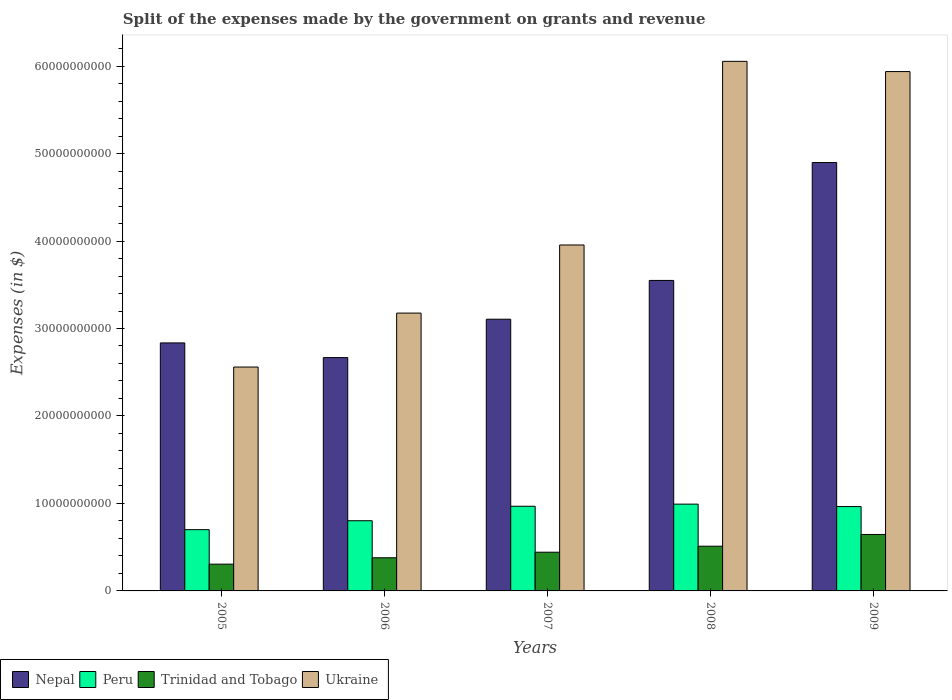How many different coloured bars are there?
Your answer should be very brief. 4. Are the number of bars per tick equal to the number of legend labels?
Give a very brief answer. Yes. How many bars are there on the 5th tick from the right?
Provide a succinct answer. 4. What is the label of the 2nd group of bars from the left?
Provide a short and direct response. 2006. In how many cases, is the number of bars for a given year not equal to the number of legend labels?
Keep it short and to the point. 0. What is the expenses made by the government on grants and revenue in Ukraine in 2005?
Keep it short and to the point. 2.56e+1. Across all years, what is the maximum expenses made by the government on grants and revenue in Nepal?
Provide a succinct answer. 4.90e+1. Across all years, what is the minimum expenses made by the government on grants and revenue in Ukraine?
Ensure brevity in your answer.  2.56e+1. In which year was the expenses made by the government on grants and revenue in Ukraine maximum?
Make the answer very short. 2008. What is the total expenses made by the government on grants and revenue in Trinidad and Tobago in the graph?
Your answer should be compact. 2.28e+1. What is the difference between the expenses made by the government on grants and revenue in Ukraine in 2006 and that in 2007?
Offer a very short reply. -7.79e+09. What is the difference between the expenses made by the government on grants and revenue in Ukraine in 2007 and the expenses made by the government on grants and revenue in Trinidad and Tobago in 2005?
Keep it short and to the point. 3.65e+1. What is the average expenses made by the government on grants and revenue in Peru per year?
Provide a succinct answer. 8.85e+09. In the year 2007, what is the difference between the expenses made by the government on grants and revenue in Nepal and expenses made by the government on grants and revenue in Trinidad and Tobago?
Provide a short and direct response. 2.66e+1. What is the ratio of the expenses made by the government on grants and revenue in Trinidad and Tobago in 2005 to that in 2007?
Your answer should be very brief. 0.69. Is the expenses made by the government on grants and revenue in Trinidad and Tobago in 2006 less than that in 2007?
Your answer should be compact. Yes. Is the difference between the expenses made by the government on grants and revenue in Nepal in 2007 and 2008 greater than the difference between the expenses made by the government on grants and revenue in Trinidad and Tobago in 2007 and 2008?
Offer a terse response. No. What is the difference between the highest and the second highest expenses made by the government on grants and revenue in Trinidad and Tobago?
Give a very brief answer. 1.34e+09. What is the difference between the highest and the lowest expenses made by the government on grants and revenue in Ukraine?
Ensure brevity in your answer.  3.49e+1. Is the sum of the expenses made by the government on grants and revenue in Peru in 2008 and 2009 greater than the maximum expenses made by the government on grants and revenue in Nepal across all years?
Your response must be concise. No. Is it the case that in every year, the sum of the expenses made by the government on grants and revenue in Ukraine and expenses made by the government on grants and revenue in Trinidad and Tobago is greater than the sum of expenses made by the government on grants and revenue in Peru and expenses made by the government on grants and revenue in Nepal?
Give a very brief answer. Yes. What does the 2nd bar from the right in 2007 represents?
Provide a succinct answer. Trinidad and Tobago. Is it the case that in every year, the sum of the expenses made by the government on grants and revenue in Trinidad and Tobago and expenses made by the government on grants and revenue in Peru is greater than the expenses made by the government on grants and revenue in Nepal?
Give a very brief answer. No. Are all the bars in the graph horizontal?
Offer a terse response. No. How many years are there in the graph?
Your answer should be compact. 5. What is the difference between two consecutive major ticks on the Y-axis?
Provide a succinct answer. 1.00e+1. Does the graph contain any zero values?
Provide a short and direct response. No. What is the title of the graph?
Your answer should be very brief. Split of the expenses made by the government on grants and revenue. What is the label or title of the Y-axis?
Offer a terse response. Expenses (in $). What is the Expenses (in $) in Nepal in 2005?
Provide a succinct answer. 2.84e+1. What is the Expenses (in $) of Peru in 2005?
Give a very brief answer. 7.00e+09. What is the Expenses (in $) in Trinidad and Tobago in 2005?
Provide a short and direct response. 3.06e+09. What is the Expenses (in $) of Ukraine in 2005?
Offer a terse response. 2.56e+1. What is the Expenses (in $) in Nepal in 2006?
Provide a succinct answer. 2.67e+1. What is the Expenses (in $) of Peru in 2006?
Provide a succinct answer. 8.02e+09. What is the Expenses (in $) of Trinidad and Tobago in 2006?
Your answer should be very brief. 3.79e+09. What is the Expenses (in $) of Ukraine in 2006?
Your answer should be very brief. 3.18e+1. What is the Expenses (in $) in Nepal in 2007?
Keep it short and to the point. 3.11e+1. What is the Expenses (in $) of Peru in 2007?
Keep it short and to the point. 9.68e+09. What is the Expenses (in $) in Trinidad and Tobago in 2007?
Provide a short and direct response. 4.42e+09. What is the Expenses (in $) in Ukraine in 2007?
Make the answer very short. 3.95e+1. What is the Expenses (in $) of Nepal in 2008?
Give a very brief answer. 3.55e+1. What is the Expenses (in $) of Peru in 2008?
Your response must be concise. 9.92e+09. What is the Expenses (in $) in Trinidad and Tobago in 2008?
Your answer should be compact. 5.11e+09. What is the Expenses (in $) in Ukraine in 2008?
Ensure brevity in your answer.  6.05e+1. What is the Expenses (in $) of Nepal in 2009?
Your response must be concise. 4.90e+1. What is the Expenses (in $) in Peru in 2009?
Offer a very short reply. 9.64e+09. What is the Expenses (in $) in Trinidad and Tobago in 2009?
Your answer should be very brief. 6.45e+09. What is the Expenses (in $) of Ukraine in 2009?
Your answer should be compact. 5.94e+1. Across all years, what is the maximum Expenses (in $) in Nepal?
Offer a very short reply. 4.90e+1. Across all years, what is the maximum Expenses (in $) of Peru?
Your answer should be compact. 9.92e+09. Across all years, what is the maximum Expenses (in $) in Trinidad and Tobago?
Offer a terse response. 6.45e+09. Across all years, what is the maximum Expenses (in $) in Ukraine?
Make the answer very short. 6.05e+1. Across all years, what is the minimum Expenses (in $) of Nepal?
Provide a short and direct response. 2.67e+1. Across all years, what is the minimum Expenses (in $) in Peru?
Provide a short and direct response. 7.00e+09. Across all years, what is the minimum Expenses (in $) of Trinidad and Tobago?
Your answer should be very brief. 3.06e+09. Across all years, what is the minimum Expenses (in $) in Ukraine?
Provide a short and direct response. 2.56e+1. What is the total Expenses (in $) in Nepal in the graph?
Your response must be concise. 1.71e+11. What is the total Expenses (in $) of Peru in the graph?
Provide a short and direct response. 4.43e+1. What is the total Expenses (in $) of Trinidad and Tobago in the graph?
Provide a short and direct response. 2.28e+1. What is the total Expenses (in $) in Ukraine in the graph?
Your answer should be very brief. 2.17e+11. What is the difference between the Expenses (in $) in Nepal in 2005 and that in 2006?
Your response must be concise. 1.68e+09. What is the difference between the Expenses (in $) in Peru in 2005 and that in 2006?
Provide a succinct answer. -1.02e+09. What is the difference between the Expenses (in $) in Trinidad and Tobago in 2005 and that in 2006?
Your answer should be very brief. -7.30e+08. What is the difference between the Expenses (in $) of Ukraine in 2005 and that in 2006?
Offer a terse response. -6.17e+09. What is the difference between the Expenses (in $) of Nepal in 2005 and that in 2007?
Provide a succinct answer. -2.71e+09. What is the difference between the Expenses (in $) in Peru in 2005 and that in 2007?
Keep it short and to the point. -2.68e+09. What is the difference between the Expenses (in $) of Trinidad and Tobago in 2005 and that in 2007?
Provide a succinct answer. -1.36e+09. What is the difference between the Expenses (in $) in Ukraine in 2005 and that in 2007?
Give a very brief answer. -1.40e+1. What is the difference between the Expenses (in $) of Nepal in 2005 and that in 2008?
Offer a terse response. -7.14e+09. What is the difference between the Expenses (in $) of Peru in 2005 and that in 2008?
Provide a short and direct response. -2.92e+09. What is the difference between the Expenses (in $) in Trinidad and Tobago in 2005 and that in 2008?
Your response must be concise. -2.05e+09. What is the difference between the Expenses (in $) in Ukraine in 2005 and that in 2008?
Ensure brevity in your answer.  -3.49e+1. What is the difference between the Expenses (in $) in Nepal in 2005 and that in 2009?
Ensure brevity in your answer.  -2.06e+1. What is the difference between the Expenses (in $) in Peru in 2005 and that in 2009?
Keep it short and to the point. -2.64e+09. What is the difference between the Expenses (in $) of Trinidad and Tobago in 2005 and that in 2009?
Provide a succinct answer. -3.40e+09. What is the difference between the Expenses (in $) in Ukraine in 2005 and that in 2009?
Make the answer very short. -3.38e+1. What is the difference between the Expenses (in $) in Nepal in 2006 and that in 2007?
Your answer should be compact. -4.39e+09. What is the difference between the Expenses (in $) of Peru in 2006 and that in 2007?
Provide a short and direct response. -1.65e+09. What is the difference between the Expenses (in $) of Trinidad and Tobago in 2006 and that in 2007?
Make the answer very short. -6.34e+08. What is the difference between the Expenses (in $) in Ukraine in 2006 and that in 2007?
Provide a short and direct response. -7.79e+09. What is the difference between the Expenses (in $) in Nepal in 2006 and that in 2008?
Provide a succinct answer. -8.82e+09. What is the difference between the Expenses (in $) in Peru in 2006 and that in 2008?
Keep it short and to the point. -1.90e+09. What is the difference between the Expenses (in $) of Trinidad and Tobago in 2006 and that in 2008?
Offer a terse response. -1.32e+09. What is the difference between the Expenses (in $) in Ukraine in 2006 and that in 2008?
Your response must be concise. -2.88e+1. What is the difference between the Expenses (in $) of Nepal in 2006 and that in 2009?
Your answer should be very brief. -2.23e+1. What is the difference between the Expenses (in $) in Peru in 2006 and that in 2009?
Keep it short and to the point. -1.62e+09. What is the difference between the Expenses (in $) in Trinidad and Tobago in 2006 and that in 2009?
Your answer should be very brief. -2.66e+09. What is the difference between the Expenses (in $) in Ukraine in 2006 and that in 2009?
Provide a short and direct response. -2.76e+1. What is the difference between the Expenses (in $) in Nepal in 2007 and that in 2008?
Your answer should be compact. -4.43e+09. What is the difference between the Expenses (in $) in Peru in 2007 and that in 2008?
Ensure brevity in your answer.  -2.42e+08. What is the difference between the Expenses (in $) in Trinidad and Tobago in 2007 and that in 2008?
Provide a short and direct response. -6.86e+08. What is the difference between the Expenses (in $) of Ukraine in 2007 and that in 2008?
Provide a succinct answer. -2.10e+1. What is the difference between the Expenses (in $) in Nepal in 2007 and that in 2009?
Provide a short and direct response. -1.79e+1. What is the difference between the Expenses (in $) in Peru in 2007 and that in 2009?
Offer a terse response. 3.64e+07. What is the difference between the Expenses (in $) of Trinidad and Tobago in 2007 and that in 2009?
Your response must be concise. -2.03e+09. What is the difference between the Expenses (in $) of Ukraine in 2007 and that in 2009?
Provide a succinct answer. -1.98e+1. What is the difference between the Expenses (in $) of Nepal in 2008 and that in 2009?
Keep it short and to the point. -1.35e+1. What is the difference between the Expenses (in $) in Peru in 2008 and that in 2009?
Your response must be concise. 2.78e+08. What is the difference between the Expenses (in $) of Trinidad and Tobago in 2008 and that in 2009?
Provide a succinct answer. -1.34e+09. What is the difference between the Expenses (in $) in Ukraine in 2008 and that in 2009?
Keep it short and to the point. 1.17e+09. What is the difference between the Expenses (in $) of Nepal in 2005 and the Expenses (in $) of Peru in 2006?
Your answer should be compact. 2.03e+1. What is the difference between the Expenses (in $) in Nepal in 2005 and the Expenses (in $) in Trinidad and Tobago in 2006?
Your response must be concise. 2.46e+1. What is the difference between the Expenses (in $) in Nepal in 2005 and the Expenses (in $) in Ukraine in 2006?
Keep it short and to the point. -3.41e+09. What is the difference between the Expenses (in $) of Peru in 2005 and the Expenses (in $) of Trinidad and Tobago in 2006?
Give a very brief answer. 3.21e+09. What is the difference between the Expenses (in $) of Peru in 2005 and the Expenses (in $) of Ukraine in 2006?
Offer a very short reply. -2.48e+1. What is the difference between the Expenses (in $) in Trinidad and Tobago in 2005 and the Expenses (in $) in Ukraine in 2006?
Provide a short and direct response. -2.87e+1. What is the difference between the Expenses (in $) of Nepal in 2005 and the Expenses (in $) of Peru in 2007?
Provide a succinct answer. 1.87e+1. What is the difference between the Expenses (in $) of Nepal in 2005 and the Expenses (in $) of Trinidad and Tobago in 2007?
Make the answer very short. 2.39e+1. What is the difference between the Expenses (in $) in Nepal in 2005 and the Expenses (in $) in Ukraine in 2007?
Offer a terse response. -1.12e+1. What is the difference between the Expenses (in $) in Peru in 2005 and the Expenses (in $) in Trinidad and Tobago in 2007?
Keep it short and to the point. 2.58e+09. What is the difference between the Expenses (in $) of Peru in 2005 and the Expenses (in $) of Ukraine in 2007?
Provide a succinct answer. -3.25e+1. What is the difference between the Expenses (in $) in Trinidad and Tobago in 2005 and the Expenses (in $) in Ukraine in 2007?
Your answer should be very brief. -3.65e+1. What is the difference between the Expenses (in $) of Nepal in 2005 and the Expenses (in $) of Peru in 2008?
Offer a very short reply. 1.84e+1. What is the difference between the Expenses (in $) in Nepal in 2005 and the Expenses (in $) in Trinidad and Tobago in 2008?
Provide a short and direct response. 2.32e+1. What is the difference between the Expenses (in $) in Nepal in 2005 and the Expenses (in $) in Ukraine in 2008?
Give a very brief answer. -3.22e+1. What is the difference between the Expenses (in $) in Peru in 2005 and the Expenses (in $) in Trinidad and Tobago in 2008?
Your answer should be very brief. 1.89e+09. What is the difference between the Expenses (in $) of Peru in 2005 and the Expenses (in $) of Ukraine in 2008?
Provide a succinct answer. -5.35e+1. What is the difference between the Expenses (in $) of Trinidad and Tobago in 2005 and the Expenses (in $) of Ukraine in 2008?
Give a very brief answer. -5.75e+1. What is the difference between the Expenses (in $) in Nepal in 2005 and the Expenses (in $) in Peru in 2009?
Your answer should be very brief. 1.87e+1. What is the difference between the Expenses (in $) of Nepal in 2005 and the Expenses (in $) of Trinidad and Tobago in 2009?
Keep it short and to the point. 2.19e+1. What is the difference between the Expenses (in $) in Nepal in 2005 and the Expenses (in $) in Ukraine in 2009?
Your answer should be compact. -3.10e+1. What is the difference between the Expenses (in $) of Peru in 2005 and the Expenses (in $) of Trinidad and Tobago in 2009?
Provide a succinct answer. 5.48e+08. What is the difference between the Expenses (in $) of Peru in 2005 and the Expenses (in $) of Ukraine in 2009?
Offer a very short reply. -5.24e+1. What is the difference between the Expenses (in $) of Trinidad and Tobago in 2005 and the Expenses (in $) of Ukraine in 2009?
Give a very brief answer. -5.63e+1. What is the difference between the Expenses (in $) of Nepal in 2006 and the Expenses (in $) of Peru in 2007?
Offer a terse response. 1.70e+1. What is the difference between the Expenses (in $) of Nepal in 2006 and the Expenses (in $) of Trinidad and Tobago in 2007?
Give a very brief answer. 2.22e+1. What is the difference between the Expenses (in $) in Nepal in 2006 and the Expenses (in $) in Ukraine in 2007?
Give a very brief answer. -1.29e+1. What is the difference between the Expenses (in $) of Peru in 2006 and the Expenses (in $) of Trinidad and Tobago in 2007?
Provide a succinct answer. 3.60e+09. What is the difference between the Expenses (in $) of Peru in 2006 and the Expenses (in $) of Ukraine in 2007?
Keep it short and to the point. -3.15e+1. What is the difference between the Expenses (in $) of Trinidad and Tobago in 2006 and the Expenses (in $) of Ukraine in 2007?
Give a very brief answer. -3.58e+1. What is the difference between the Expenses (in $) in Nepal in 2006 and the Expenses (in $) in Peru in 2008?
Offer a terse response. 1.68e+1. What is the difference between the Expenses (in $) in Nepal in 2006 and the Expenses (in $) in Trinidad and Tobago in 2008?
Ensure brevity in your answer.  2.16e+1. What is the difference between the Expenses (in $) of Nepal in 2006 and the Expenses (in $) of Ukraine in 2008?
Provide a succinct answer. -3.39e+1. What is the difference between the Expenses (in $) in Peru in 2006 and the Expenses (in $) in Trinidad and Tobago in 2008?
Your response must be concise. 2.91e+09. What is the difference between the Expenses (in $) of Peru in 2006 and the Expenses (in $) of Ukraine in 2008?
Your answer should be compact. -5.25e+1. What is the difference between the Expenses (in $) in Trinidad and Tobago in 2006 and the Expenses (in $) in Ukraine in 2008?
Your answer should be very brief. -5.67e+1. What is the difference between the Expenses (in $) of Nepal in 2006 and the Expenses (in $) of Peru in 2009?
Your answer should be compact. 1.70e+1. What is the difference between the Expenses (in $) in Nepal in 2006 and the Expenses (in $) in Trinidad and Tobago in 2009?
Your answer should be very brief. 2.02e+1. What is the difference between the Expenses (in $) in Nepal in 2006 and the Expenses (in $) in Ukraine in 2009?
Offer a terse response. -3.27e+1. What is the difference between the Expenses (in $) in Peru in 2006 and the Expenses (in $) in Trinidad and Tobago in 2009?
Keep it short and to the point. 1.57e+09. What is the difference between the Expenses (in $) in Peru in 2006 and the Expenses (in $) in Ukraine in 2009?
Your response must be concise. -5.13e+1. What is the difference between the Expenses (in $) of Trinidad and Tobago in 2006 and the Expenses (in $) of Ukraine in 2009?
Offer a terse response. -5.56e+1. What is the difference between the Expenses (in $) of Nepal in 2007 and the Expenses (in $) of Peru in 2008?
Offer a very short reply. 2.11e+1. What is the difference between the Expenses (in $) in Nepal in 2007 and the Expenses (in $) in Trinidad and Tobago in 2008?
Ensure brevity in your answer.  2.60e+1. What is the difference between the Expenses (in $) of Nepal in 2007 and the Expenses (in $) of Ukraine in 2008?
Make the answer very short. -2.95e+1. What is the difference between the Expenses (in $) in Peru in 2007 and the Expenses (in $) in Trinidad and Tobago in 2008?
Your answer should be very brief. 4.57e+09. What is the difference between the Expenses (in $) of Peru in 2007 and the Expenses (in $) of Ukraine in 2008?
Give a very brief answer. -5.09e+1. What is the difference between the Expenses (in $) of Trinidad and Tobago in 2007 and the Expenses (in $) of Ukraine in 2008?
Make the answer very short. -5.61e+1. What is the difference between the Expenses (in $) of Nepal in 2007 and the Expenses (in $) of Peru in 2009?
Keep it short and to the point. 2.14e+1. What is the difference between the Expenses (in $) in Nepal in 2007 and the Expenses (in $) in Trinidad and Tobago in 2009?
Offer a terse response. 2.46e+1. What is the difference between the Expenses (in $) of Nepal in 2007 and the Expenses (in $) of Ukraine in 2009?
Your response must be concise. -2.83e+1. What is the difference between the Expenses (in $) in Peru in 2007 and the Expenses (in $) in Trinidad and Tobago in 2009?
Offer a very short reply. 3.22e+09. What is the difference between the Expenses (in $) in Peru in 2007 and the Expenses (in $) in Ukraine in 2009?
Your answer should be compact. -4.97e+1. What is the difference between the Expenses (in $) in Trinidad and Tobago in 2007 and the Expenses (in $) in Ukraine in 2009?
Ensure brevity in your answer.  -5.49e+1. What is the difference between the Expenses (in $) in Nepal in 2008 and the Expenses (in $) in Peru in 2009?
Your answer should be very brief. 2.59e+1. What is the difference between the Expenses (in $) of Nepal in 2008 and the Expenses (in $) of Trinidad and Tobago in 2009?
Your response must be concise. 2.90e+1. What is the difference between the Expenses (in $) of Nepal in 2008 and the Expenses (in $) of Ukraine in 2009?
Offer a terse response. -2.39e+1. What is the difference between the Expenses (in $) in Peru in 2008 and the Expenses (in $) in Trinidad and Tobago in 2009?
Your response must be concise. 3.47e+09. What is the difference between the Expenses (in $) in Peru in 2008 and the Expenses (in $) in Ukraine in 2009?
Provide a succinct answer. -4.95e+1. What is the difference between the Expenses (in $) of Trinidad and Tobago in 2008 and the Expenses (in $) of Ukraine in 2009?
Offer a very short reply. -5.43e+1. What is the average Expenses (in $) of Nepal per year?
Your answer should be compact. 3.41e+1. What is the average Expenses (in $) in Peru per year?
Provide a succinct answer. 8.85e+09. What is the average Expenses (in $) of Trinidad and Tobago per year?
Your answer should be very brief. 4.57e+09. What is the average Expenses (in $) of Ukraine per year?
Provide a succinct answer. 4.34e+1. In the year 2005, what is the difference between the Expenses (in $) of Nepal and Expenses (in $) of Peru?
Provide a succinct answer. 2.13e+1. In the year 2005, what is the difference between the Expenses (in $) in Nepal and Expenses (in $) in Trinidad and Tobago?
Provide a short and direct response. 2.53e+1. In the year 2005, what is the difference between the Expenses (in $) in Nepal and Expenses (in $) in Ukraine?
Make the answer very short. 2.76e+09. In the year 2005, what is the difference between the Expenses (in $) of Peru and Expenses (in $) of Trinidad and Tobago?
Ensure brevity in your answer.  3.94e+09. In the year 2005, what is the difference between the Expenses (in $) of Peru and Expenses (in $) of Ukraine?
Make the answer very short. -1.86e+1. In the year 2005, what is the difference between the Expenses (in $) in Trinidad and Tobago and Expenses (in $) in Ukraine?
Provide a short and direct response. -2.25e+1. In the year 2006, what is the difference between the Expenses (in $) of Nepal and Expenses (in $) of Peru?
Your answer should be compact. 1.86e+1. In the year 2006, what is the difference between the Expenses (in $) of Nepal and Expenses (in $) of Trinidad and Tobago?
Keep it short and to the point. 2.29e+1. In the year 2006, what is the difference between the Expenses (in $) in Nepal and Expenses (in $) in Ukraine?
Your answer should be very brief. -5.09e+09. In the year 2006, what is the difference between the Expenses (in $) of Peru and Expenses (in $) of Trinidad and Tobago?
Provide a short and direct response. 4.23e+09. In the year 2006, what is the difference between the Expenses (in $) in Peru and Expenses (in $) in Ukraine?
Provide a short and direct response. -2.37e+1. In the year 2006, what is the difference between the Expenses (in $) in Trinidad and Tobago and Expenses (in $) in Ukraine?
Ensure brevity in your answer.  -2.80e+1. In the year 2007, what is the difference between the Expenses (in $) of Nepal and Expenses (in $) of Peru?
Your response must be concise. 2.14e+1. In the year 2007, what is the difference between the Expenses (in $) in Nepal and Expenses (in $) in Trinidad and Tobago?
Give a very brief answer. 2.66e+1. In the year 2007, what is the difference between the Expenses (in $) of Nepal and Expenses (in $) of Ukraine?
Your response must be concise. -8.49e+09. In the year 2007, what is the difference between the Expenses (in $) in Peru and Expenses (in $) in Trinidad and Tobago?
Make the answer very short. 5.25e+09. In the year 2007, what is the difference between the Expenses (in $) of Peru and Expenses (in $) of Ukraine?
Offer a very short reply. -2.99e+1. In the year 2007, what is the difference between the Expenses (in $) in Trinidad and Tobago and Expenses (in $) in Ukraine?
Give a very brief answer. -3.51e+1. In the year 2008, what is the difference between the Expenses (in $) of Nepal and Expenses (in $) of Peru?
Your answer should be very brief. 2.56e+1. In the year 2008, what is the difference between the Expenses (in $) of Nepal and Expenses (in $) of Trinidad and Tobago?
Your answer should be very brief. 3.04e+1. In the year 2008, what is the difference between the Expenses (in $) in Nepal and Expenses (in $) in Ukraine?
Provide a succinct answer. -2.50e+1. In the year 2008, what is the difference between the Expenses (in $) in Peru and Expenses (in $) in Trinidad and Tobago?
Ensure brevity in your answer.  4.81e+09. In the year 2008, what is the difference between the Expenses (in $) in Peru and Expenses (in $) in Ukraine?
Provide a succinct answer. -5.06e+1. In the year 2008, what is the difference between the Expenses (in $) of Trinidad and Tobago and Expenses (in $) of Ukraine?
Offer a very short reply. -5.54e+1. In the year 2009, what is the difference between the Expenses (in $) of Nepal and Expenses (in $) of Peru?
Your answer should be very brief. 3.93e+1. In the year 2009, what is the difference between the Expenses (in $) in Nepal and Expenses (in $) in Trinidad and Tobago?
Give a very brief answer. 4.25e+1. In the year 2009, what is the difference between the Expenses (in $) in Nepal and Expenses (in $) in Ukraine?
Provide a short and direct response. -1.04e+1. In the year 2009, what is the difference between the Expenses (in $) of Peru and Expenses (in $) of Trinidad and Tobago?
Offer a very short reply. 3.19e+09. In the year 2009, what is the difference between the Expenses (in $) of Peru and Expenses (in $) of Ukraine?
Offer a terse response. -4.97e+1. In the year 2009, what is the difference between the Expenses (in $) of Trinidad and Tobago and Expenses (in $) of Ukraine?
Offer a very short reply. -5.29e+1. What is the ratio of the Expenses (in $) of Nepal in 2005 to that in 2006?
Ensure brevity in your answer.  1.06. What is the ratio of the Expenses (in $) in Peru in 2005 to that in 2006?
Offer a terse response. 0.87. What is the ratio of the Expenses (in $) of Trinidad and Tobago in 2005 to that in 2006?
Offer a terse response. 0.81. What is the ratio of the Expenses (in $) of Ukraine in 2005 to that in 2006?
Keep it short and to the point. 0.81. What is the ratio of the Expenses (in $) of Nepal in 2005 to that in 2007?
Provide a short and direct response. 0.91. What is the ratio of the Expenses (in $) of Peru in 2005 to that in 2007?
Offer a very short reply. 0.72. What is the ratio of the Expenses (in $) of Trinidad and Tobago in 2005 to that in 2007?
Give a very brief answer. 0.69. What is the ratio of the Expenses (in $) in Ukraine in 2005 to that in 2007?
Your answer should be very brief. 0.65. What is the ratio of the Expenses (in $) in Nepal in 2005 to that in 2008?
Give a very brief answer. 0.8. What is the ratio of the Expenses (in $) in Peru in 2005 to that in 2008?
Provide a short and direct response. 0.71. What is the ratio of the Expenses (in $) of Trinidad and Tobago in 2005 to that in 2008?
Your answer should be very brief. 0.6. What is the ratio of the Expenses (in $) of Ukraine in 2005 to that in 2008?
Your response must be concise. 0.42. What is the ratio of the Expenses (in $) in Nepal in 2005 to that in 2009?
Ensure brevity in your answer.  0.58. What is the ratio of the Expenses (in $) in Peru in 2005 to that in 2009?
Offer a very short reply. 0.73. What is the ratio of the Expenses (in $) of Trinidad and Tobago in 2005 to that in 2009?
Your response must be concise. 0.47. What is the ratio of the Expenses (in $) of Ukraine in 2005 to that in 2009?
Ensure brevity in your answer.  0.43. What is the ratio of the Expenses (in $) in Nepal in 2006 to that in 2007?
Offer a very short reply. 0.86. What is the ratio of the Expenses (in $) in Peru in 2006 to that in 2007?
Make the answer very short. 0.83. What is the ratio of the Expenses (in $) of Trinidad and Tobago in 2006 to that in 2007?
Your answer should be very brief. 0.86. What is the ratio of the Expenses (in $) of Ukraine in 2006 to that in 2007?
Provide a short and direct response. 0.8. What is the ratio of the Expenses (in $) of Nepal in 2006 to that in 2008?
Your response must be concise. 0.75. What is the ratio of the Expenses (in $) in Peru in 2006 to that in 2008?
Your answer should be very brief. 0.81. What is the ratio of the Expenses (in $) of Trinidad and Tobago in 2006 to that in 2008?
Ensure brevity in your answer.  0.74. What is the ratio of the Expenses (in $) of Ukraine in 2006 to that in 2008?
Give a very brief answer. 0.52. What is the ratio of the Expenses (in $) of Nepal in 2006 to that in 2009?
Your answer should be very brief. 0.54. What is the ratio of the Expenses (in $) of Peru in 2006 to that in 2009?
Provide a short and direct response. 0.83. What is the ratio of the Expenses (in $) of Trinidad and Tobago in 2006 to that in 2009?
Your answer should be compact. 0.59. What is the ratio of the Expenses (in $) in Ukraine in 2006 to that in 2009?
Provide a succinct answer. 0.54. What is the ratio of the Expenses (in $) of Nepal in 2007 to that in 2008?
Your answer should be compact. 0.88. What is the ratio of the Expenses (in $) in Peru in 2007 to that in 2008?
Give a very brief answer. 0.98. What is the ratio of the Expenses (in $) of Trinidad and Tobago in 2007 to that in 2008?
Your response must be concise. 0.87. What is the ratio of the Expenses (in $) in Ukraine in 2007 to that in 2008?
Your answer should be very brief. 0.65. What is the ratio of the Expenses (in $) in Nepal in 2007 to that in 2009?
Your answer should be very brief. 0.63. What is the ratio of the Expenses (in $) in Peru in 2007 to that in 2009?
Offer a terse response. 1. What is the ratio of the Expenses (in $) in Trinidad and Tobago in 2007 to that in 2009?
Keep it short and to the point. 0.69. What is the ratio of the Expenses (in $) in Ukraine in 2007 to that in 2009?
Offer a very short reply. 0.67. What is the ratio of the Expenses (in $) in Nepal in 2008 to that in 2009?
Offer a very short reply. 0.72. What is the ratio of the Expenses (in $) in Peru in 2008 to that in 2009?
Your answer should be compact. 1.03. What is the ratio of the Expenses (in $) of Trinidad and Tobago in 2008 to that in 2009?
Keep it short and to the point. 0.79. What is the ratio of the Expenses (in $) of Ukraine in 2008 to that in 2009?
Your response must be concise. 1.02. What is the difference between the highest and the second highest Expenses (in $) of Nepal?
Give a very brief answer. 1.35e+1. What is the difference between the highest and the second highest Expenses (in $) of Peru?
Offer a terse response. 2.42e+08. What is the difference between the highest and the second highest Expenses (in $) of Trinidad and Tobago?
Offer a terse response. 1.34e+09. What is the difference between the highest and the second highest Expenses (in $) of Ukraine?
Offer a terse response. 1.17e+09. What is the difference between the highest and the lowest Expenses (in $) in Nepal?
Provide a succinct answer. 2.23e+1. What is the difference between the highest and the lowest Expenses (in $) of Peru?
Your response must be concise. 2.92e+09. What is the difference between the highest and the lowest Expenses (in $) in Trinidad and Tobago?
Your answer should be compact. 3.40e+09. What is the difference between the highest and the lowest Expenses (in $) of Ukraine?
Your answer should be compact. 3.49e+1. 